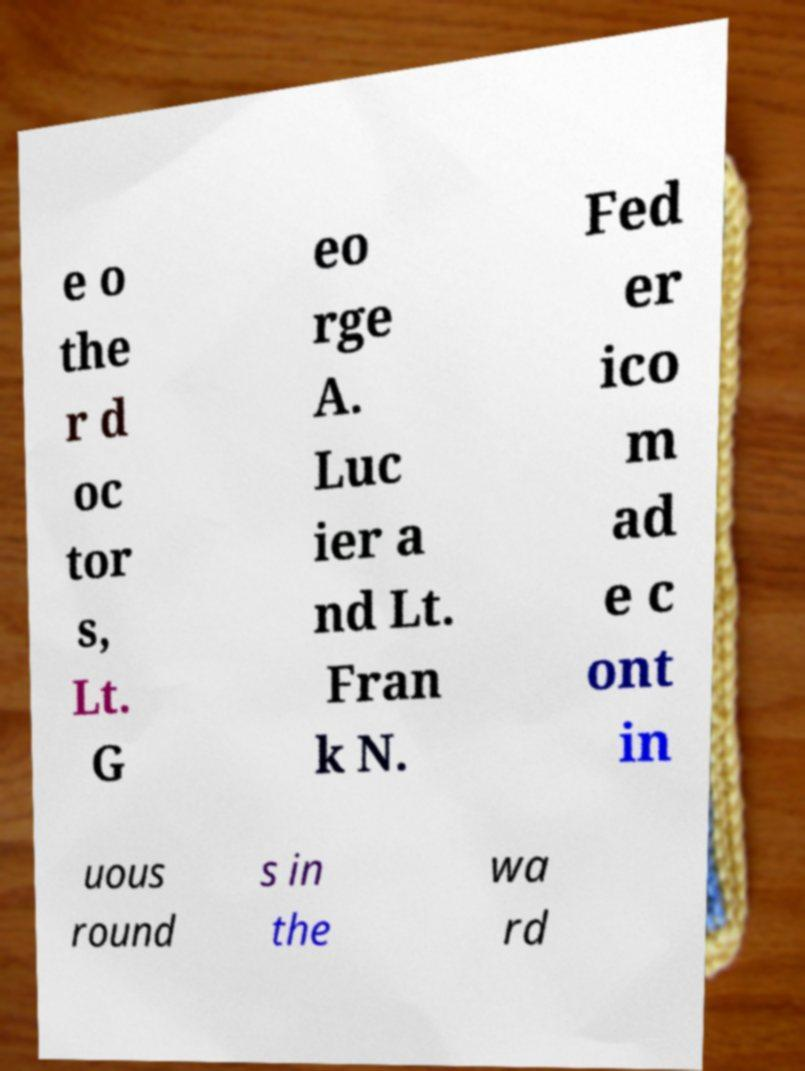Can you accurately transcribe the text from the provided image for me? e o the r d oc tor s, Lt. G eo rge A. Luc ier a nd Lt. Fran k N. Fed er ico m ad e c ont in uous round s in the wa rd 